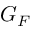<formula> <loc_0><loc_0><loc_500><loc_500>G _ { F }</formula> 